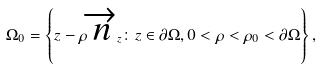<formula> <loc_0><loc_0><loc_500><loc_500>\Omega _ { 0 } = \left \{ z - \rho \overrightarrow { n } _ { z } \colon z \in \partial \Omega , 0 < \rho < \rho _ { 0 } < \partial \Omega \right \} ,</formula> 